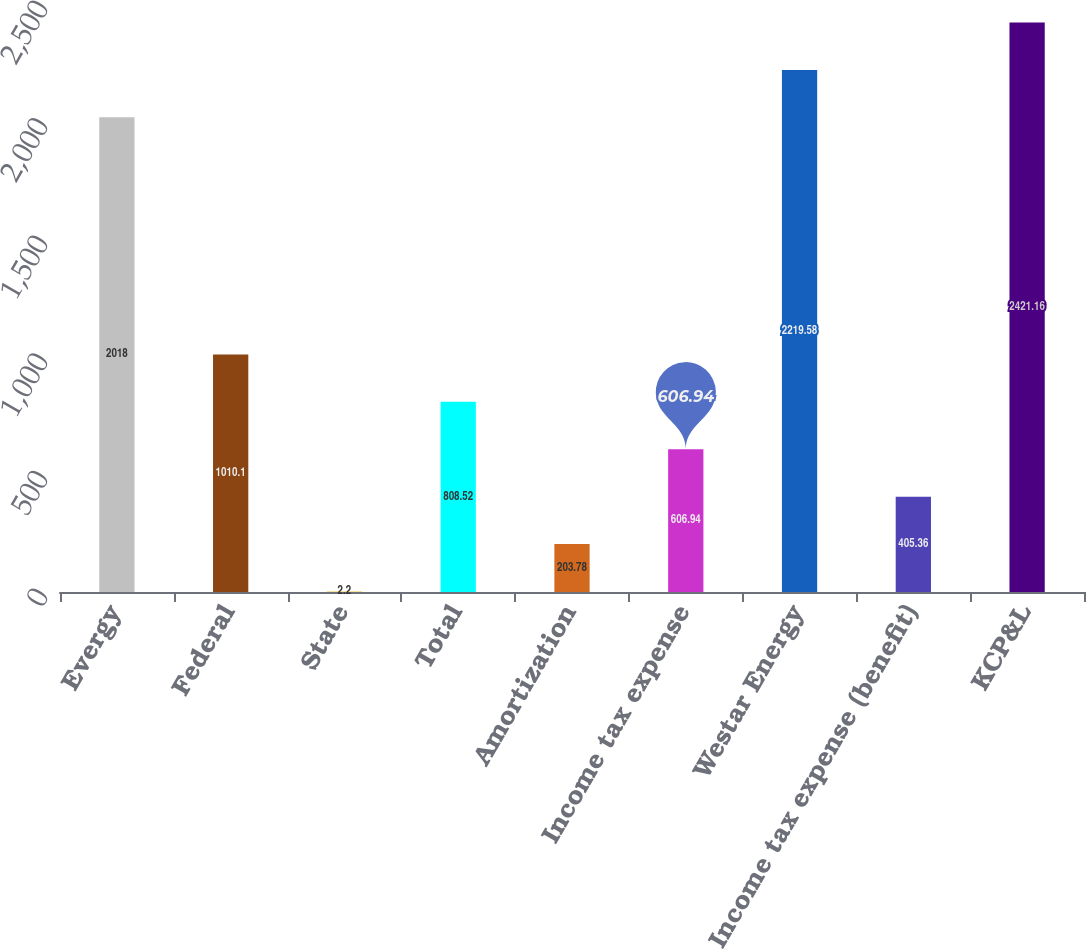Convert chart. <chart><loc_0><loc_0><loc_500><loc_500><bar_chart><fcel>Evergy<fcel>Federal<fcel>State<fcel>Total<fcel>Amortization<fcel>Income tax expense<fcel>Westar Energy<fcel>Income tax expense (benefit)<fcel>KCP&L<nl><fcel>2018<fcel>1010.1<fcel>2.2<fcel>808.52<fcel>203.78<fcel>606.94<fcel>2219.58<fcel>405.36<fcel>2421.16<nl></chart> 